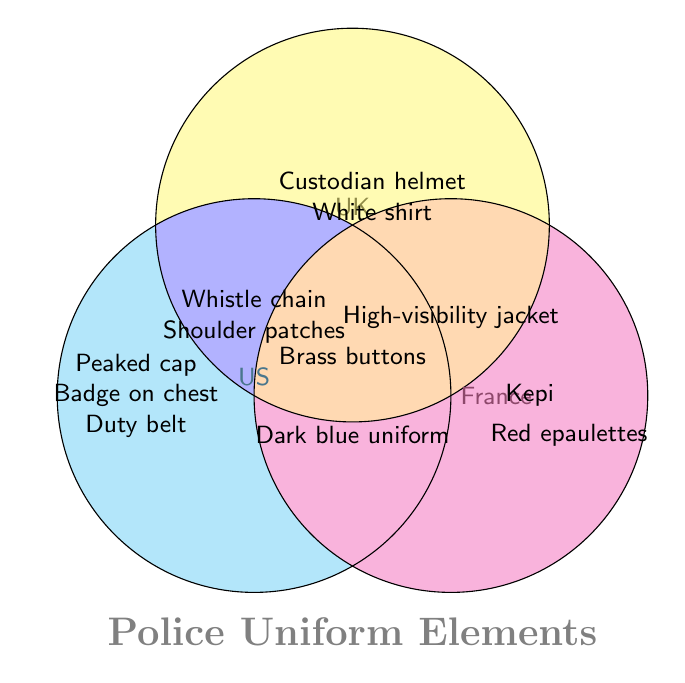What countries have a dark blue uniform as part of their police uniform styles? The Venn Diagram shows the dark blue uniform in the overlapping area of all three circles, indicating that the US, UK, and France all have this uniform style.
Answer: US, UK, France What unique element does France have in its police uniform style that is not shared with the US or the UK? The diagram shows that in France’s section alone, there is the Kepi and Red epaulettes, which are only found in French police uniforms and not in the US or the UK.
Answer: Kepi, Red epaulettes Which items are common between the US, UK, and France's police uniforms? Items that belong to the intersection of all three circles represent elements common to all three countries. From the diagram, these are Dark blue uniform and Brass buttons.
Answer: Dark blue uniform, Brass buttons What uniform style is found in both the UK and France, but not in the US? Within the overlapping section between the UK and France only, the shared uniform style is the High-visibility jacket.
Answer: High-visibility jacket Which elements are exclusive to the UK's police uniforms? By looking at the section labeled "UK" and not intersecting with any other circle, we find Custodian helmet and White shirt.
Answer: Custodian helmet, White shirt What do the US and UK police uniforms have in common? The overlapping area between the US and UK circles contains Whistle chain and Shoulder patches.
Answer: Whistle chain, Shoulder patches Can you list an element that all three countries' police uniforms share? In the intersection of all three circles, we see Brass buttons.
Answer: Brass buttons What elements are unique to the US in their police uniforms? The only elements contained within the US circle, without overlap, are Peaked cap, Badge on chest, and Duty belt.
Answer: Peaked cap, Badge on chest, Duty belt 